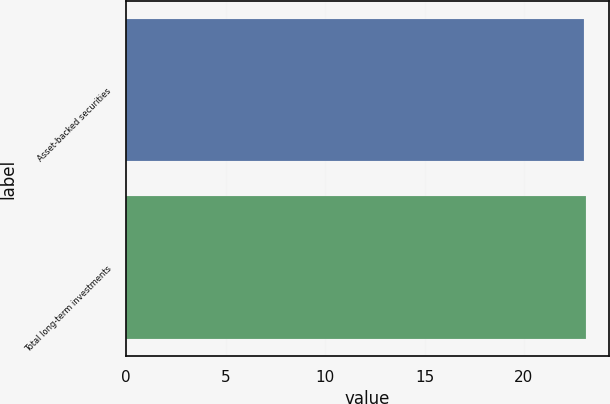Convert chart to OTSL. <chart><loc_0><loc_0><loc_500><loc_500><bar_chart><fcel>Asset-backed securities<fcel>Total long-term investments<nl><fcel>23<fcel>23.1<nl></chart> 